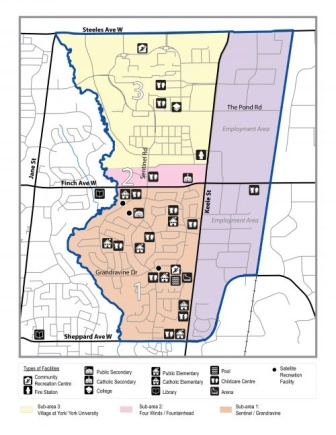If this map was from a fantasy world, what could each section represent in that context? In a fantasy world, the top section, predominantly residential, could be the 'Northern Village', a serene area where magical beings reside, filled with enchanted cottages and mystic gardens. The middle section, being commercial, could transform into the 'Merchant's Bazaar', a bustling hub of enchantment shops, alchemy labs, and spell-wielding smiths. The bottom section might become the 'Southern Enclave', a haven of learning where grand wizarding schools and mystical libraries are based. Each color-coded facility could represent different guilds, schools of magic, or training grounds for aspiring heroes. The streets, instead of asphalt, could be paths of illuminated crystal or ancient cobblestone, and landmarks like parks could turn into enchanted forests or dragon sanctuaries, making the neighborhood an epicenter of fantasy adventure. Could you describe a typical scenario in this fantasy setting, both long and short? Short: A young apprentice starts their day in the Northern Village, casting a spell to quicken their journey to the Merchant's Bazaar. They spend the afternoon learning enchantment techniques from the vendors, before heading to the Southern Enclave to study ancient texts in the Grand Library of Elders, ending the day in a peaceful forest meditation. And the long version? Long: As dawn breaks, the Northern Village awakens to the gentle hum of magical auras. In a quaint enchanted cottage, an apprentice rises, reciting a morning incantation that causes their belongings to organize themselves. They set off along a path of glowing crystals that light the way to the Merchant's Bazaar. The air is filled with the aroma of magical herbs and the sound of spells being practiced. At the Bazaar, the apprentice spends the day learning from seasoned enchanters, mastering the creation of potions and enchanted items. As midday approaches, they enjoy a meal made by a cook who uses mystic ingredients that bring warmth and vitality. In the afternoon, the apprentice makes their way to the Southern Enclave, where towering wizarding schools and libraries await. They spend hours in the Grand Library of Elders, poring over ancient scrolls under the guidance of wise scholars. As evening descends, the apprentice visits an enchanted forest on the outskirts, a serene area filled with luminescent flora. They meditate, replenishing their magical energy before returning home. The day ends with the apprentice casting a protection spell around their cottage, ensuring a safe, restful night, ready to embrace more magical adventures. 